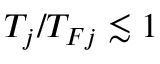Convert formula to latex. <formula><loc_0><loc_0><loc_500><loc_500>T _ { j } / T _ { F j } \lesssim 1</formula> 